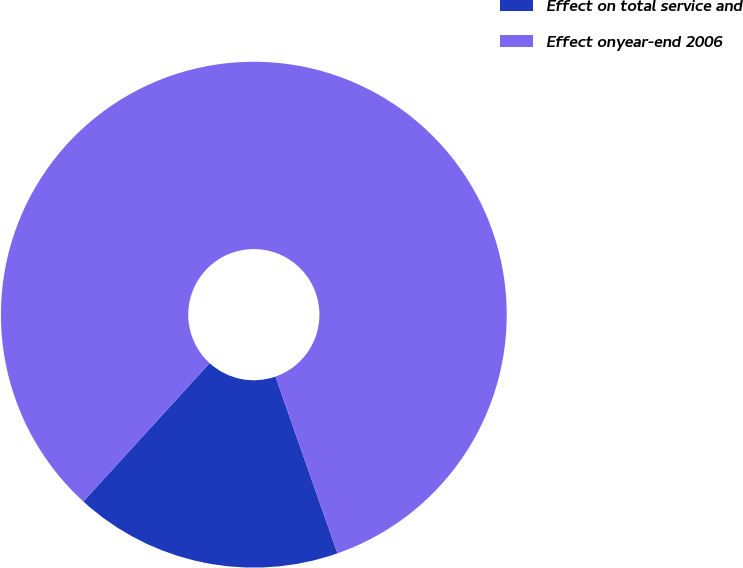Convert chart. <chart><loc_0><loc_0><loc_500><loc_500><pie_chart><fcel>Effect on total service and<fcel>Effect onyear-end 2006<nl><fcel>17.14%<fcel>82.86%<nl></chart> 